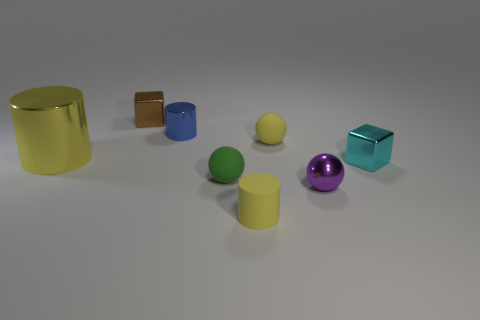The big cylinder that is made of the same material as the tiny purple ball is what color?
Keep it short and to the point. Yellow. There is a yellow cylinder behind the small rubber ball that is in front of the cyan block; what number of large metallic cylinders are on the left side of it?
Your answer should be compact. 0. There is a small ball that is the same color as the big shiny cylinder; what is its material?
Offer a very short reply. Rubber. Is there anything else that is the same shape as the green matte thing?
Make the answer very short. Yes. What number of objects are either tiny cubes that are in front of the tiny brown block or small brown objects?
Offer a very short reply. 2. Is the color of the tiny matte object that is to the right of the yellow matte cylinder the same as the metallic sphere?
Provide a succinct answer. No. What shape is the tiny yellow thing that is in front of the tiny metal block that is right of the tiny yellow rubber cylinder?
Ensure brevity in your answer.  Cylinder. Are there fewer yellow spheres that are left of the blue metallic thing than matte cylinders that are to the left of the tiny green matte object?
Your response must be concise. No. What is the size of the cyan metallic object that is the same shape as the small brown object?
Your response must be concise. Small. Are there any other things that are the same size as the shiny ball?
Offer a very short reply. Yes. 